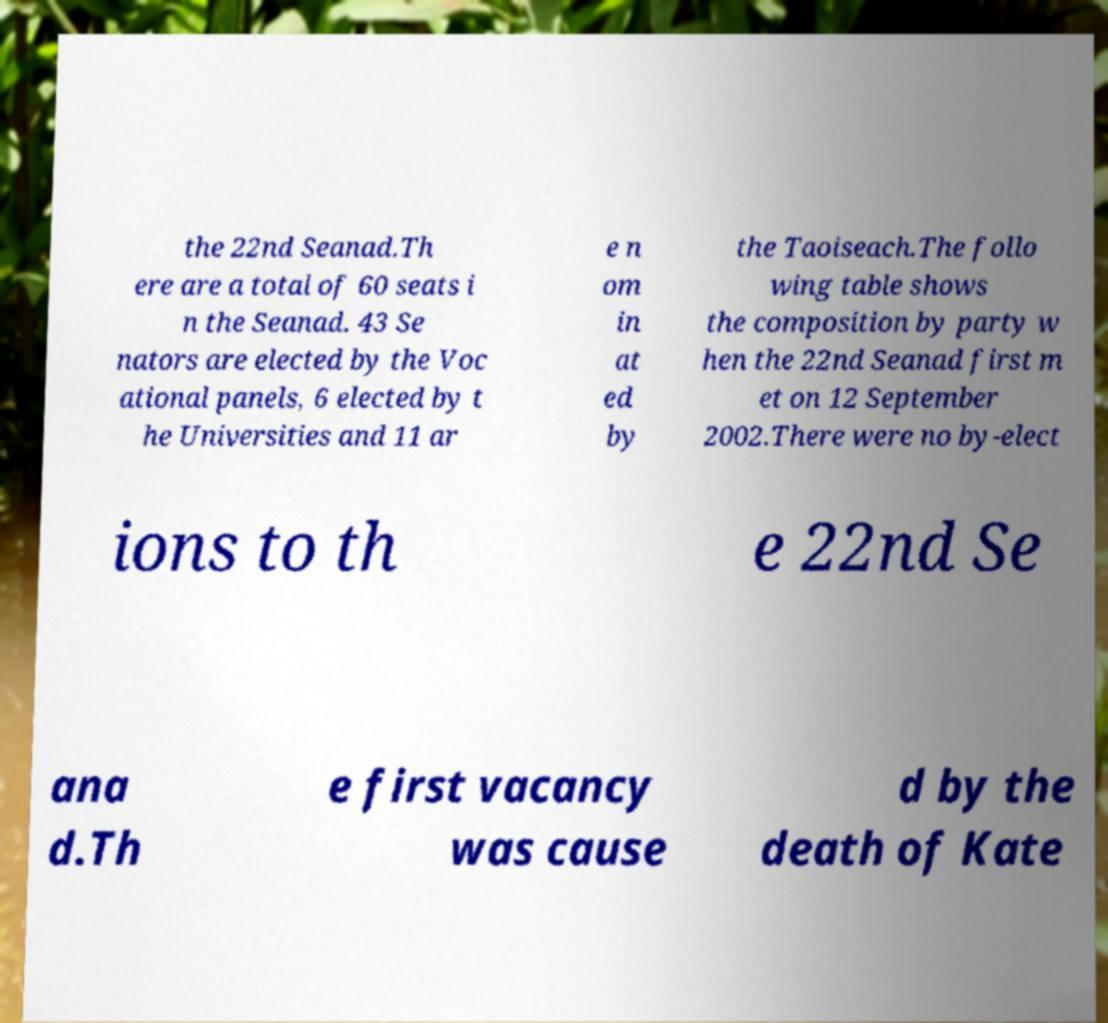Could you extract and type out the text from this image? the 22nd Seanad.Th ere are a total of 60 seats i n the Seanad. 43 Se nators are elected by the Voc ational panels, 6 elected by t he Universities and 11 ar e n om in at ed by the Taoiseach.The follo wing table shows the composition by party w hen the 22nd Seanad first m et on 12 September 2002.There were no by-elect ions to th e 22nd Se ana d.Th e first vacancy was cause d by the death of Kate 